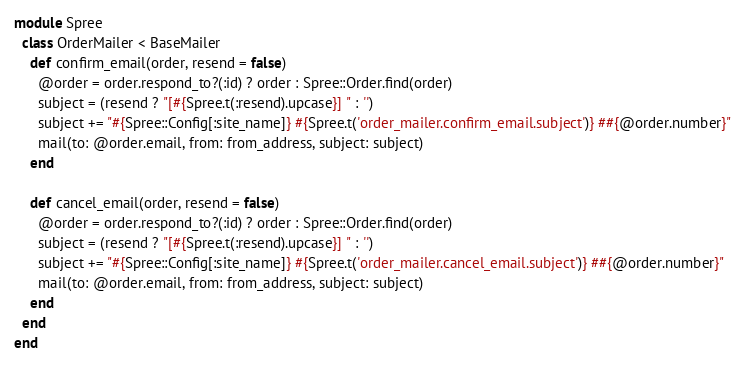<code> <loc_0><loc_0><loc_500><loc_500><_Ruby_>module Spree
  class OrderMailer < BaseMailer
    def confirm_email(order, resend = false)
      @order = order.respond_to?(:id) ? order : Spree::Order.find(order)
      subject = (resend ? "[#{Spree.t(:resend).upcase}] " : '')
      subject += "#{Spree::Config[:site_name]} #{Spree.t('order_mailer.confirm_email.subject')} ##{@order.number}"
      mail(to: @order.email, from: from_address, subject: subject)
    end

    def cancel_email(order, resend = false)
      @order = order.respond_to?(:id) ? order : Spree::Order.find(order)
      subject = (resend ? "[#{Spree.t(:resend).upcase}] " : '')
      subject += "#{Spree::Config[:site_name]} #{Spree.t('order_mailer.cancel_email.subject')} ##{@order.number}"
      mail(to: @order.email, from: from_address, subject: subject)
    end
  end
end
</code> 